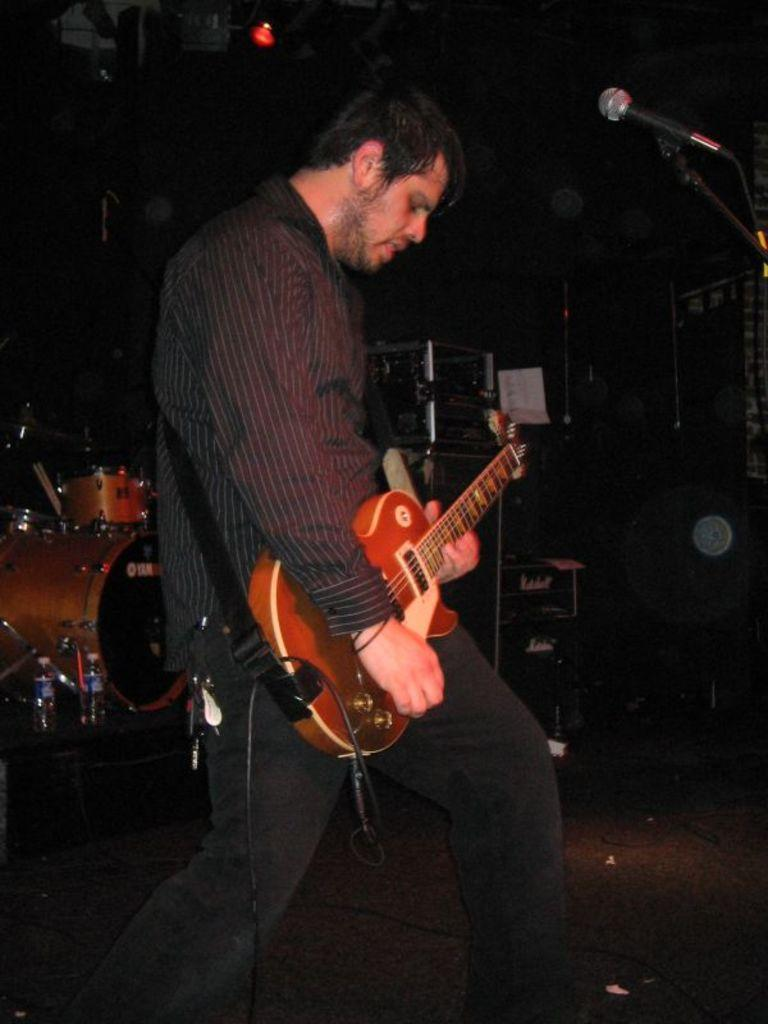What is the person in the image doing? The person in the image is playing a guitar. What is the person using to amplify their voice? There is a microphone in front of the person. What other musical instrument is visible in the image? A: There are drums behind the person. What can be seen on the left side behind the person? There are water bottles on the left side behind the person. What type of effect does the creator of the guitar have on the music in the image? The image does not provide information about the creator of the guitar or any specific effects on the music. 